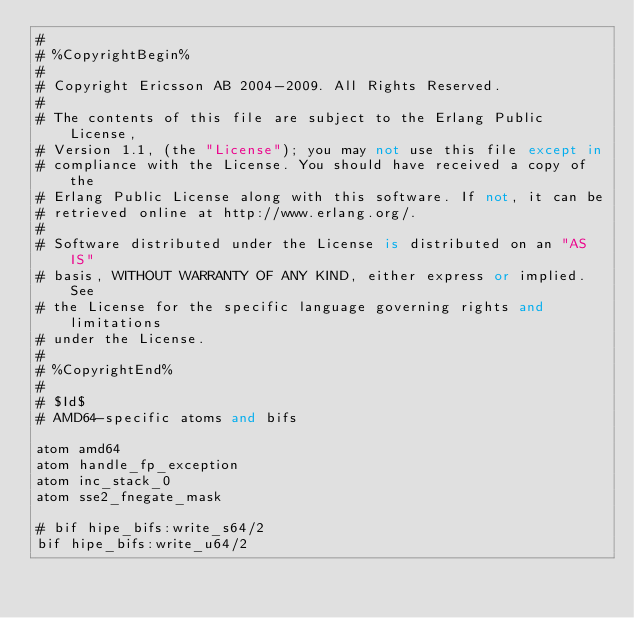<code> <loc_0><loc_0><loc_500><loc_500><_SQL_>#
# %CopyrightBegin%
# 
# Copyright Ericsson AB 2004-2009. All Rights Reserved.
# 
# The contents of this file are subject to the Erlang Public License,
# Version 1.1, (the "License"); you may not use this file except in
# compliance with the License. You should have received a copy of the
# Erlang Public License along with this software. If not, it can be
# retrieved online at http://www.erlang.org/.
# 
# Software distributed under the License is distributed on an "AS IS"
# basis, WITHOUT WARRANTY OF ANY KIND, either express or implied. See
# the License for the specific language governing rights and limitations
# under the License.
# 
# %CopyrightEnd%
#
# $Id$
# AMD64-specific atoms and bifs

atom amd64
atom handle_fp_exception
atom inc_stack_0
atom sse2_fnegate_mask

# bif hipe_bifs:write_s64/2
bif hipe_bifs:write_u64/2
</code> 